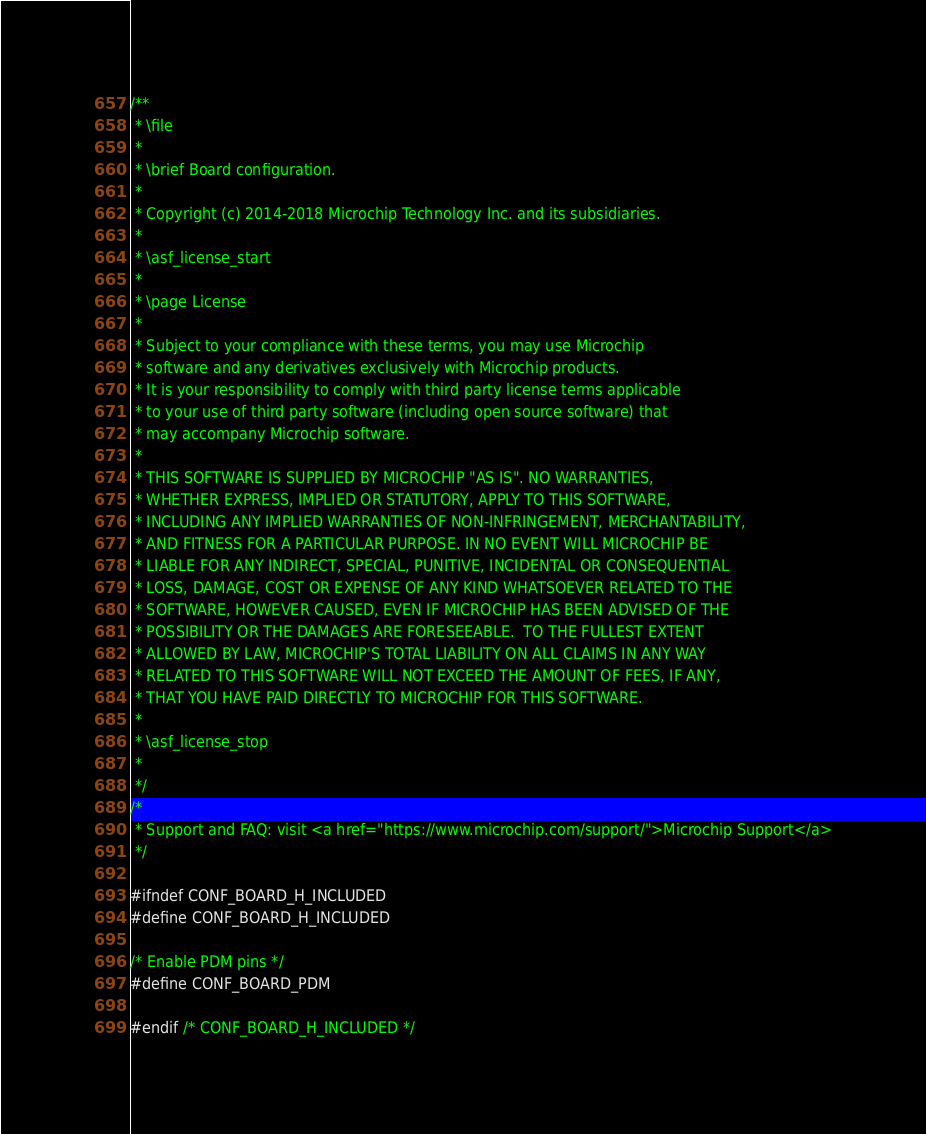<code> <loc_0><loc_0><loc_500><loc_500><_C_>/**
 * \file
 *
 * \brief Board configuration.
 *
 * Copyright (c) 2014-2018 Microchip Technology Inc. and its subsidiaries.
 *
 * \asf_license_start
 *
 * \page License
 *
 * Subject to your compliance with these terms, you may use Microchip
 * software and any derivatives exclusively with Microchip products.
 * It is your responsibility to comply with third party license terms applicable
 * to your use of third party software (including open source software) that
 * may accompany Microchip software.
 *
 * THIS SOFTWARE IS SUPPLIED BY MICROCHIP "AS IS". NO WARRANTIES,
 * WHETHER EXPRESS, IMPLIED OR STATUTORY, APPLY TO THIS SOFTWARE,
 * INCLUDING ANY IMPLIED WARRANTIES OF NON-INFRINGEMENT, MERCHANTABILITY,
 * AND FITNESS FOR A PARTICULAR PURPOSE. IN NO EVENT WILL MICROCHIP BE
 * LIABLE FOR ANY INDIRECT, SPECIAL, PUNITIVE, INCIDENTAL OR CONSEQUENTIAL
 * LOSS, DAMAGE, COST OR EXPENSE OF ANY KIND WHATSOEVER RELATED TO THE
 * SOFTWARE, HOWEVER CAUSED, EVEN IF MICROCHIP HAS BEEN ADVISED OF THE
 * POSSIBILITY OR THE DAMAGES ARE FORESEEABLE.  TO THE FULLEST EXTENT
 * ALLOWED BY LAW, MICROCHIP'S TOTAL LIABILITY ON ALL CLAIMS IN ANY WAY
 * RELATED TO THIS SOFTWARE WILL NOT EXCEED THE AMOUNT OF FEES, IF ANY,
 * THAT YOU HAVE PAID DIRECTLY TO MICROCHIP FOR THIS SOFTWARE.
 *
 * \asf_license_stop
 *
 */
/*
 * Support and FAQ: visit <a href="https://www.microchip.com/support/">Microchip Support</a>
 */

#ifndef CONF_BOARD_H_INCLUDED
#define CONF_BOARD_H_INCLUDED

/* Enable PDM pins */
#define CONF_BOARD_PDM

#endif /* CONF_BOARD_H_INCLUDED */
</code> 